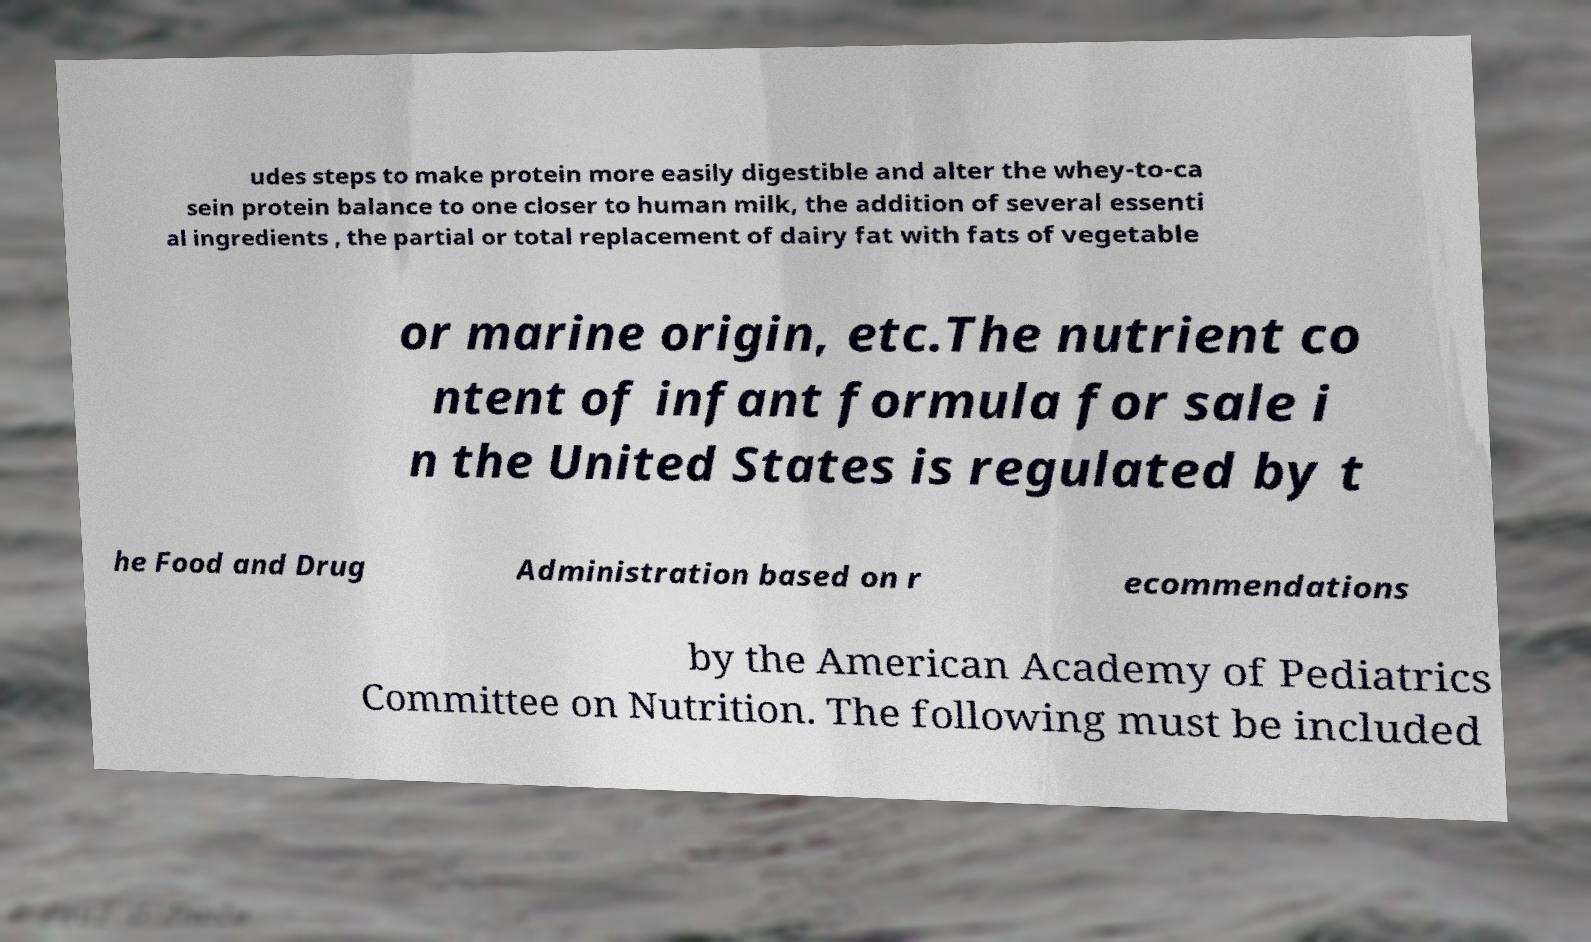For documentation purposes, I need the text within this image transcribed. Could you provide that? udes steps to make protein more easily digestible and alter the whey-to-ca sein protein balance to one closer to human milk, the addition of several essenti al ingredients , the partial or total replacement of dairy fat with fats of vegetable or marine origin, etc.The nutrient co ntent of infant formula for sale i n the United States is regulated by t he Food and Drug Administration based on r ecommendations by the American Academy of Pediatrics Committee on Nutrition. The following must be included 